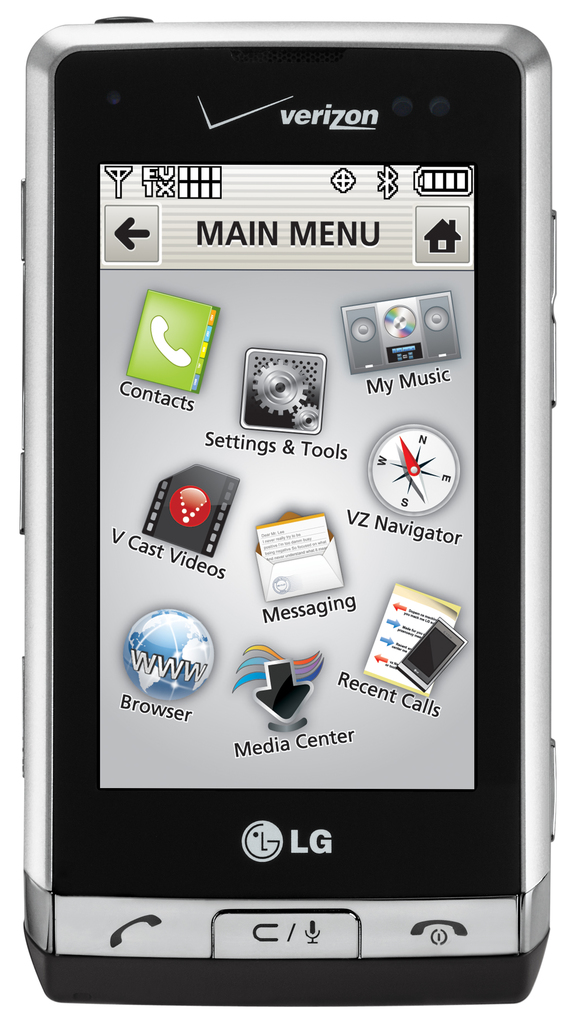Provide a one-sentence caption for the provided image. The image shows a Verizon-branded LG mobile phone, model VX10000 Voyager, displaying its main menu with various applications such as Contacts, My Music, and Messaging clearly visible. 